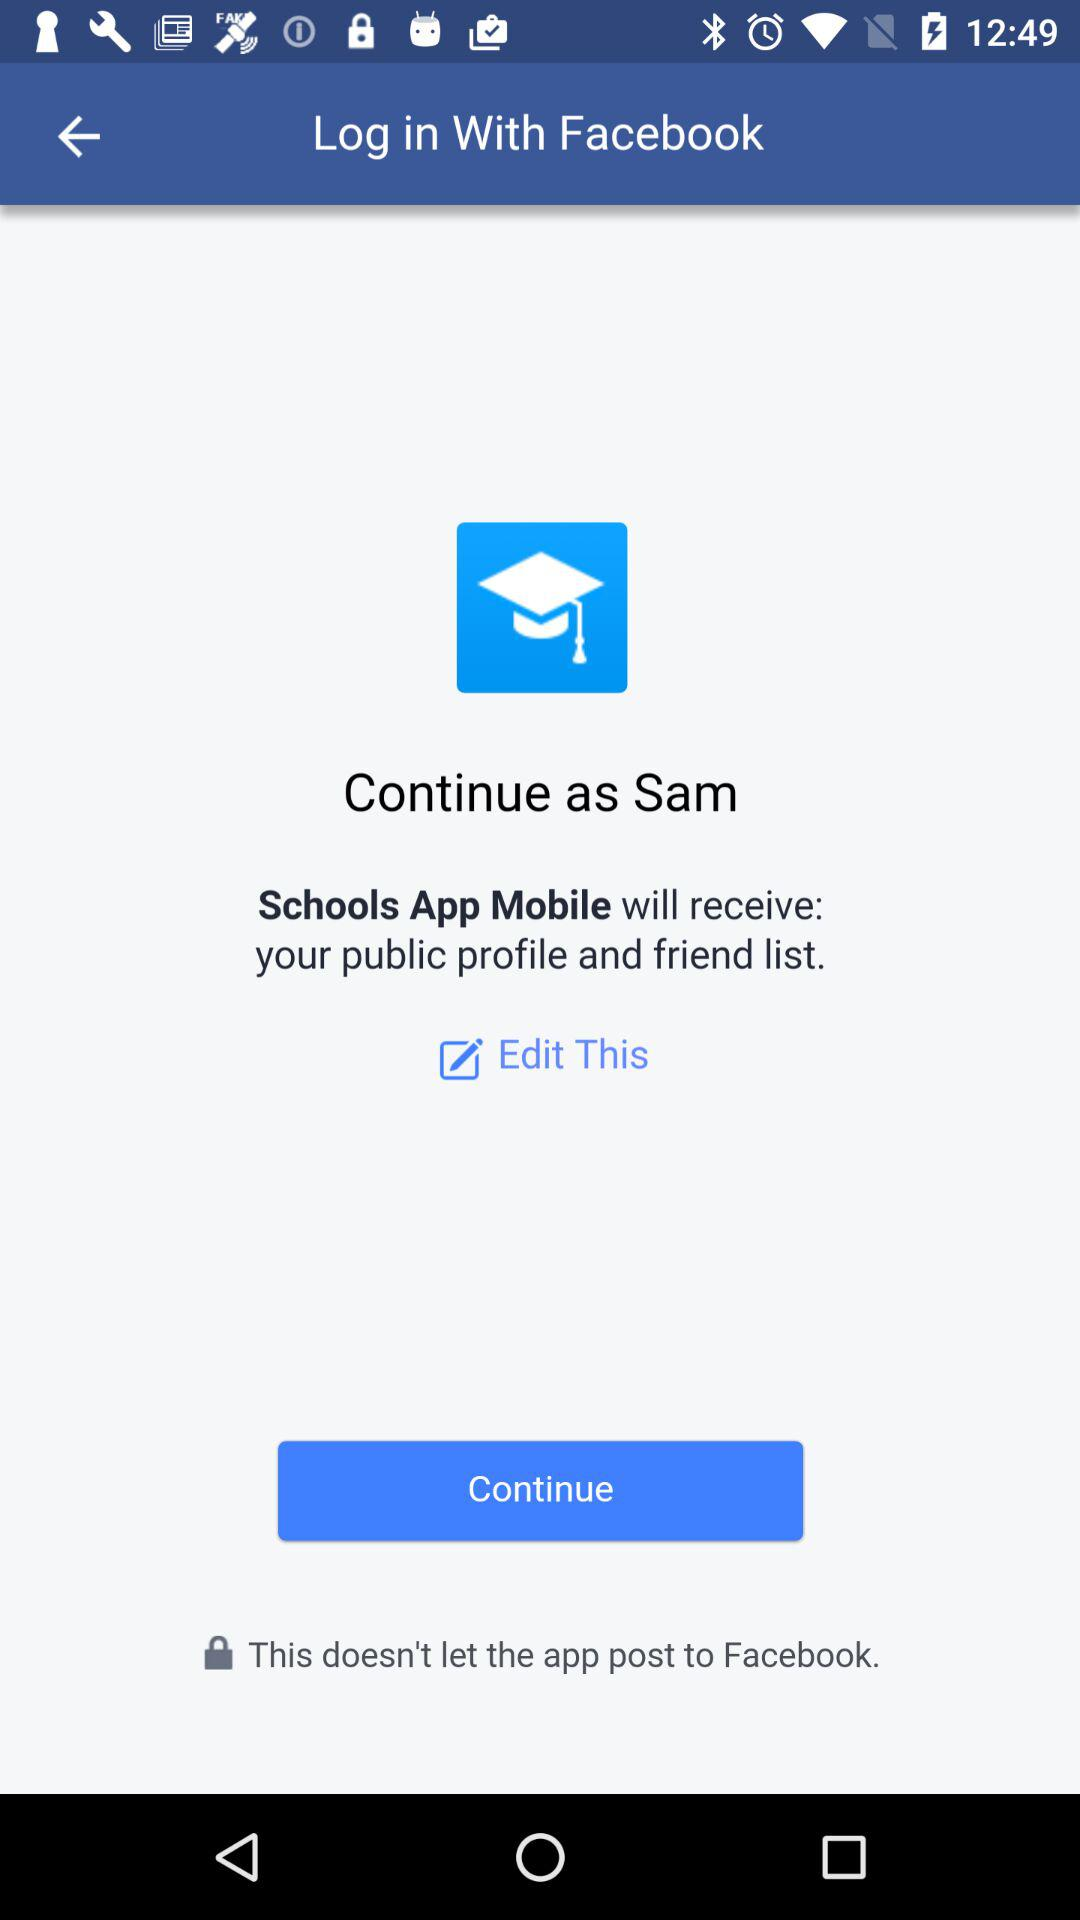What is the login name? The login name is Sam. 